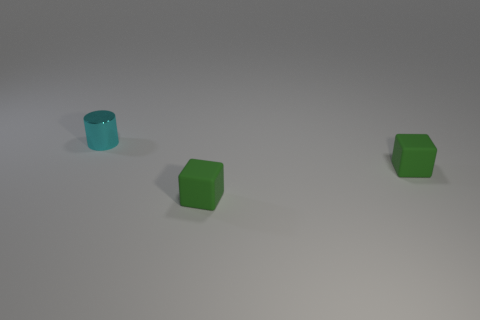If I were to touch one of the objects, what texture do you think it would have? Given the smooth and reflective surfaces visible on the cylinders and cubes, they would likely feel sleek and possibly made of a material like plastic or polished wood, depending on the actual materials used. 